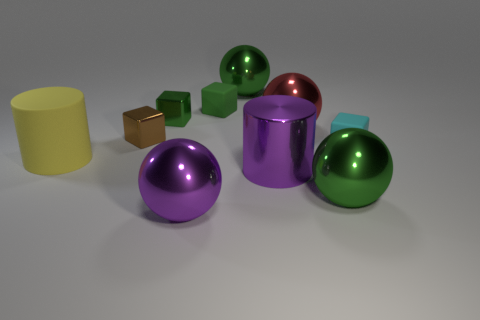What number of matte objects are green spheres or big brown cylinders?
Your response must be concise. 0. There is a brown metallic cube that is left of the green sphere that is behind the cyan rubber block; how big is it?
Ensure brevity in your answer.  Small. There is a small matte block that is to the left of the small cyan rubber cube; is it the same color as the small metal object that is on the right side of the brown block?
Your answer should be very brief. Yes. What is the color of the matte object that is both left of the cyan matte cube and behind the yellow cylinder?
Provide a short and direct response. Green. Is the material of the small cyan block the same as the purple cylinder?
Your answer should be compact. No. How many big objects are either gray shiny balls or brown metal blocks?
Make the answer very short. 0. What is the color of the tiny block that is made of the same material as the small cyan object?
Provide a succinct answer. Green. The object that is to the left of the brown cube is what color?
Your answer should be compact. Yellow. What number of big objects have the same color as the big metal cylinder?
Provide a short and direct response. 1. Is the number of small cyan rubber things that are to the left of the brown cube less than the number of metallic balls that are on the right side of the large yellow thing?
Ensure brevity in your answer.  Yes. 